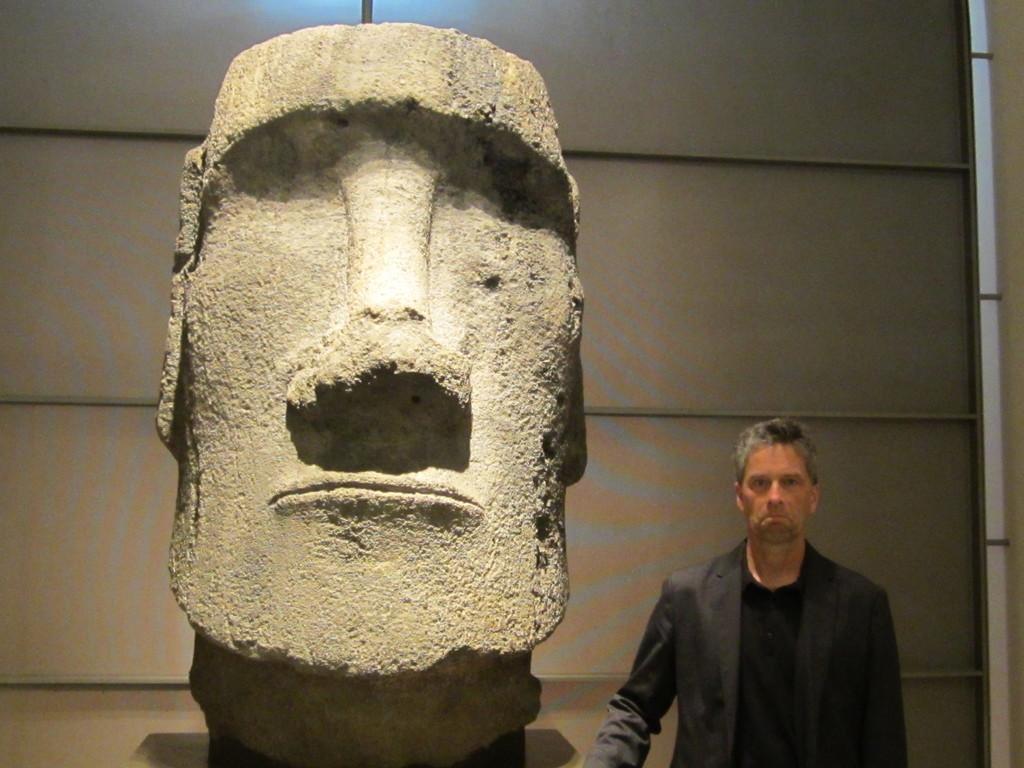Describe this image in one or two sentences. In the center of the image, there is a sculpture and on the bottom right, there is a man standing. 